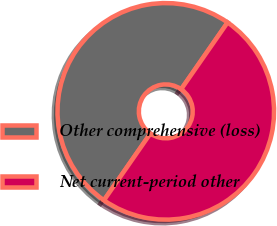<chart> <loc_0><loc_0><loc_500><loc_500><pie_chart><fcel>Other comprehensive (loss)<fcel>Net current-period other<nl><fcel>50.0%<fcel>50.0%<nl></chart> 